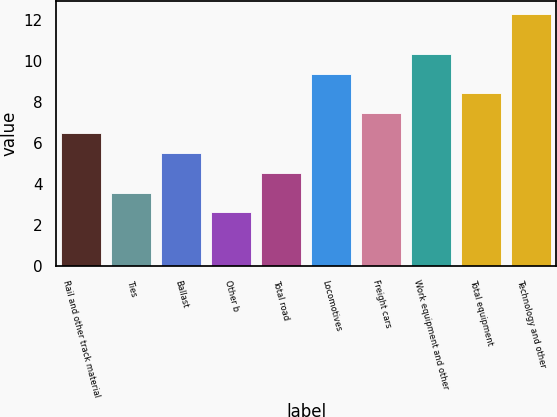<chart> <loc_0><loc_0><loc_500><loc_500><bar_chart><fcel>Rail and other track material<fcel>Ties<fcel>Ballast<fcel>Other b<fcel>Total road<fcel>Locomotives<fcel>Freight cars<fcel>Work equipment and other<fcel>Total equipment<fcel>Technology and other<nl><fcel>6.48<fcel>3.57<fcel>5.51<fcel>2.6<fcel>4.54<fcel>9.39<fcel>7.45<fcel>10.36<fcel>8.42<fcel>12.3<nl></chart> 